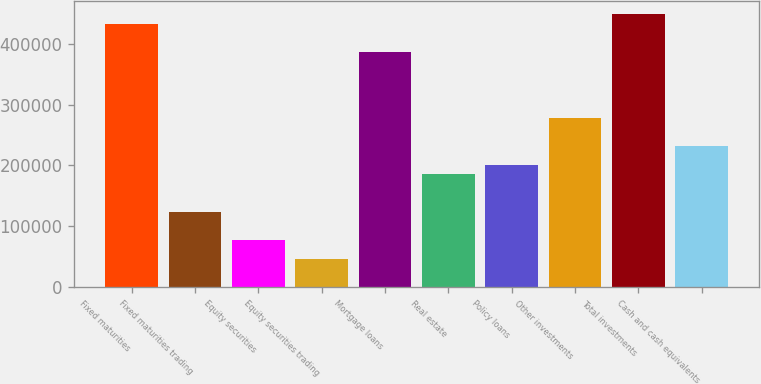<chart> <loc_0><loc_0><loc_500><loc_500><bar_chart><fcel>Fixed maturities<fcel>Fixed maturities trading<fcel>Equity securities<fcel>Equity securities trading<fcel>Mortgage loans<fcel>Real estate<fcel>Policy loans<fcel>Other investments<fcel>Total investments<fcel>Cash and cash equivalents<nl><fcel>432656<fcel>123616<fcel>77260.1<fcel>46356.1<fcel>386300<fcel>185424<fcel>200876<fcel>278136<fcel>448108<fcel>231780<nl></chart> 